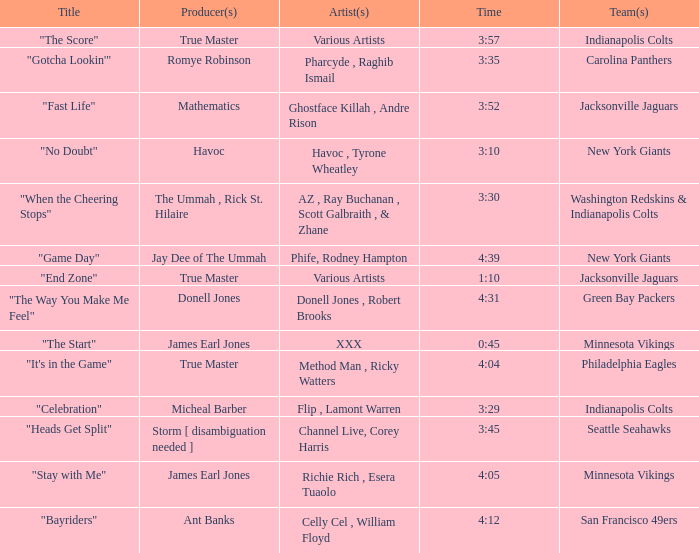How long is the XXX track used by the Minnesota Vikings? 0:45. 